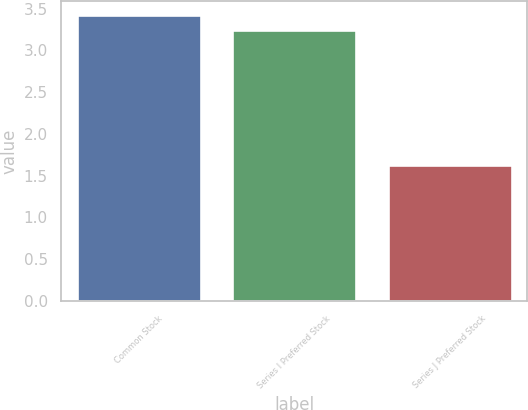<chart> <loc_0><loc_0><loc_500><loc_500><bar_chart><fcel>Common Stock<fcel>Series I Preferred Stock<fcel>Series J Preferred Stock<nl><fcel>3.42<fcel>3.25<fcel>1.63<nl></chart> 